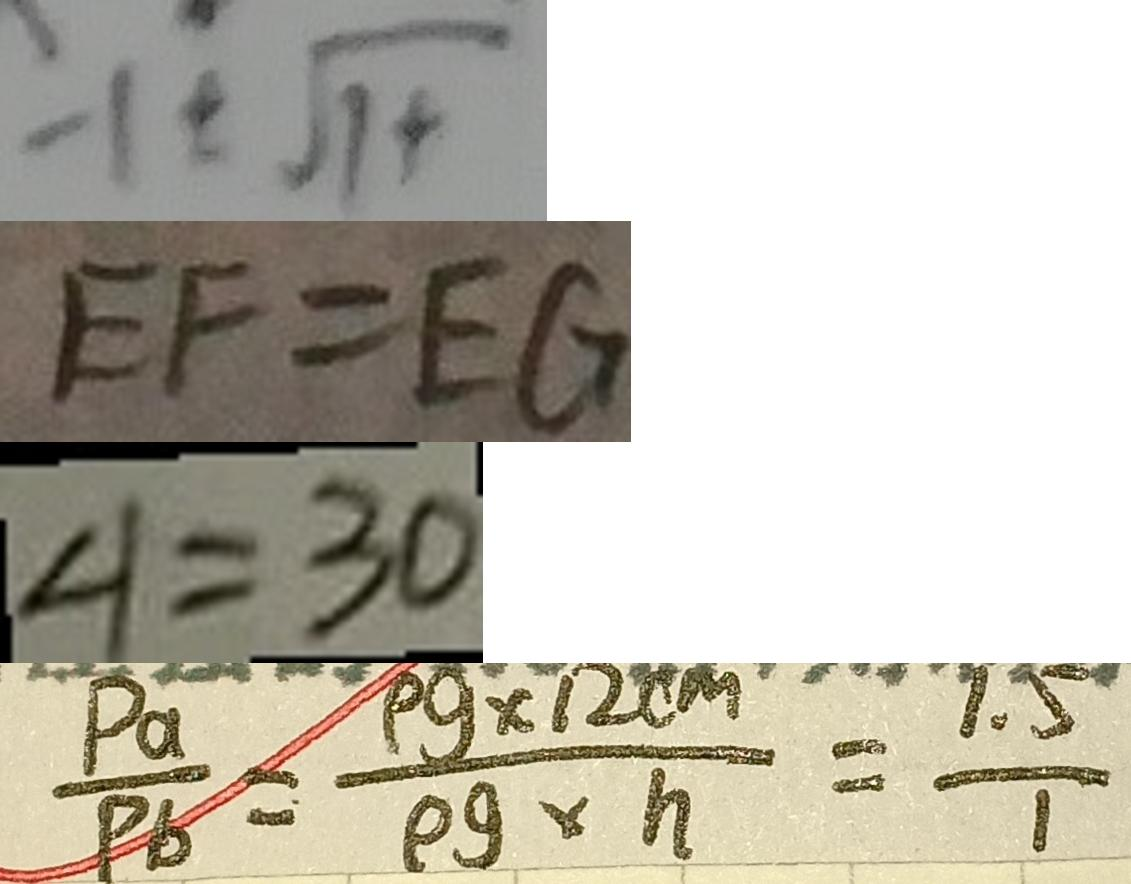Convert formula to latex. <formula><loc_0><loc_0><loc_500><loc_500>: 1 \pm \sqrt { 1 + } 
 E F = E G 
 \angle 1 = 3 0 
 \frac { P a } { P b } = \frac { \rho g \times 1 2 c m ^ { 2 } } { \rho g \times h } = \frac { 1 . 5 } { 1 }</formula> 